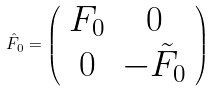<formula> <loc_0><loc_0><loc_500><loc_500>\hat { F } _ { 0 } = \left ( \begin{array} { c c } F _ { 0 } & 0 \\ 0 & - \tilde { F } _ { 0 } \end{array} \right )</formula> 